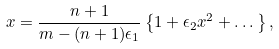Convert formula to latex. <formula><loc_0><loc_0><loc_500><loc_500>x = \frac { n + 1 } { m - ( n + 1 ) \epsilon _ { 1 } } \left \{ 1 + \epsilon _ { 2 } x ^ { 2 } + \dots \right \} ,</formula> 